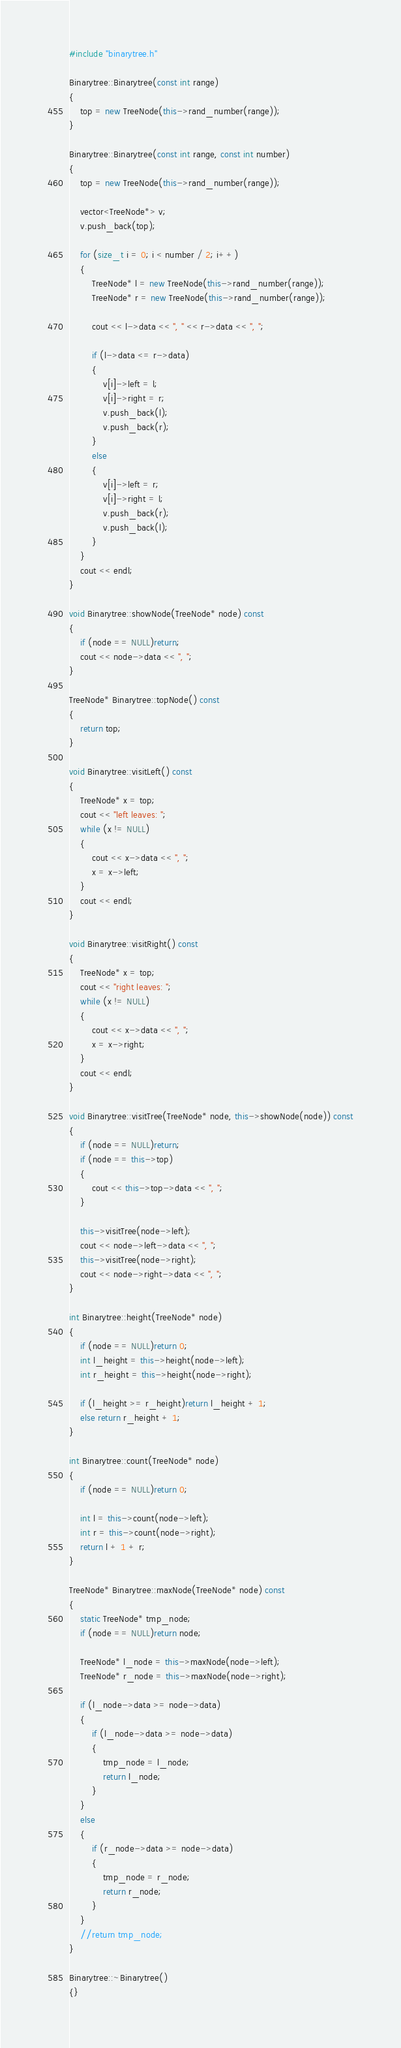Convert code to text. <code><loc_0><loc_0><loc_500><loc_500><_C++_>#include "binarytree.h"

Binarytree::Binarytree(const int range)
{
	top = new TreeNode(this->rand_number(range));
}

Binarytree::Binarytree(const int range, const int number)
{
	top = new TreeNode(this->rand_number(range));

	vector<TreeNode*> v;
	v.push_back(top);

	for (size_t i = 0; i < number / 2; i++)
	{
		TreeNode* l = new TreeNode(this->rand_number(range));
		TreeNode* r = new TreeNode(this->rand_number(range));

		cout << l->data << ", " << r->data << ", ";

		if (l->data <= r->data)
		{
			v[i]->left = l;
			v[i]->right = r;
			v.push_back(l);
			v.push_back(r);
		}
		else
		{
			v[i]->left = r;
			v[i]->right = l;
			v.push_back(r);
			v.push_back(l);
		}
	}
	cout << endl;
}

void Binarytree::showNode(TreeNode* node) const
{
	if (node == NULL)return;
	cout << node->data << ", ";
}

TreeNode* Binarytree::topNode() const
{
	return top;
}

void Binarytree::visitLeft() const
{
	TreeNode* x = top;
	cout << "left leaves: ";
	while (x != NULL)
	{
		cout << x->data << ", ";
		x = x->left;
	}
	cout << endl;
}

void Binarytree::visitRight() const
{
	TreeNode* x = top;
	cout << "right leaves: ";
	while (x != NULL)
	{
		cout << x->data << ", ";
		x = x->right;
	}
	cout << endl;
}

void Binarytree::visitTree(TreeNode* node, this->showNode(node)) const
{
	if (node == NULL)return;
	if (node == this->top)
	{
		cout << this->top->data << ", ";
	}

	this->visitTree(node->left);
	cout << node->left->data << ", ";
	this->visitTree(node->right);
	cout << node->right->data << ", ";
}

int Binarytree::height(TreeNode* node)
{
	if (node == NULL)return 0;
	int l_height = this->height(node->left);
	int r_height = this->height(node->right);

	if (l_height >= r_height)return l_height + 1;
	else return r_height + 1;
}

int Binarytree::count(TreeNode* node)
{
	if (node == NULL)return 0;
	
	int l = this->count(node->left);
	int r = this->count(node->right);
	return l + 1 + r;
}

TreeNode* Binarytree::maxNode(TreeNode* node) const
{
	static TreeNode* tmp_node;
	if (node == NULL)return node;

	TreeNode* l_node = this->maxNode(node->left);
	TreeNode* r_node = this->maxNode(node->right);

	if (l_node->data >= node->data)
	{
		if (l_node->data >= node->data)
		{
			tmp_node = l_node;
			return l_node;
		}
	}
	else
	{
		if (r_node->data >= node->data)
		{
			tmp_node = r_node;
			return r_node;
		}
	}
	//return tmp_node;
}

Binarytree::~Binarytree()
{}</code> 